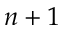Convert formula to latex. <formula><loc_0><loc_0><loc_500><loc_500>n + 1</formula> 